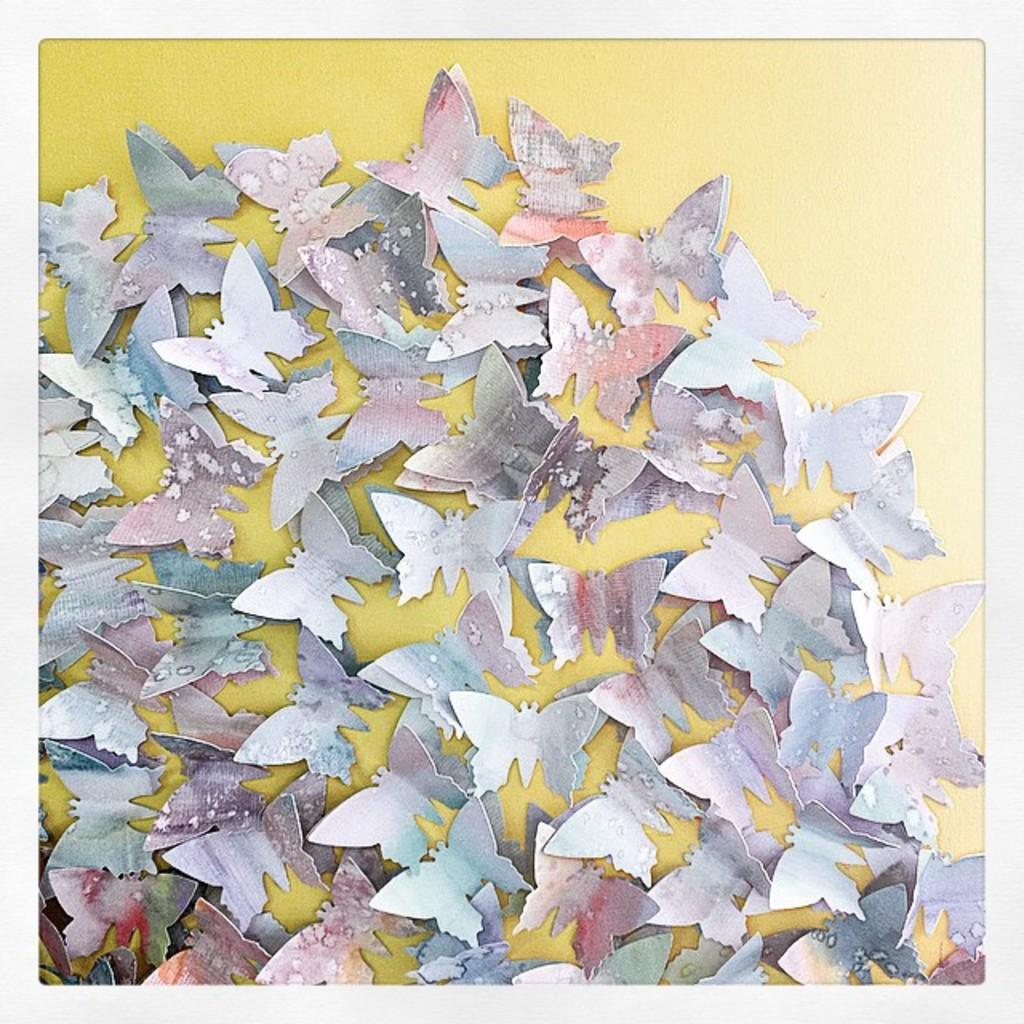What is the main subject of the image? There is a group of paper butterflies in the image. What color is the background of the image? The background of the image is yellow. What type of snail can be seen crawling on the paper butterflies in the image? There is no snail present in the image; it only features a group of paper butterflies and a yellow background. 